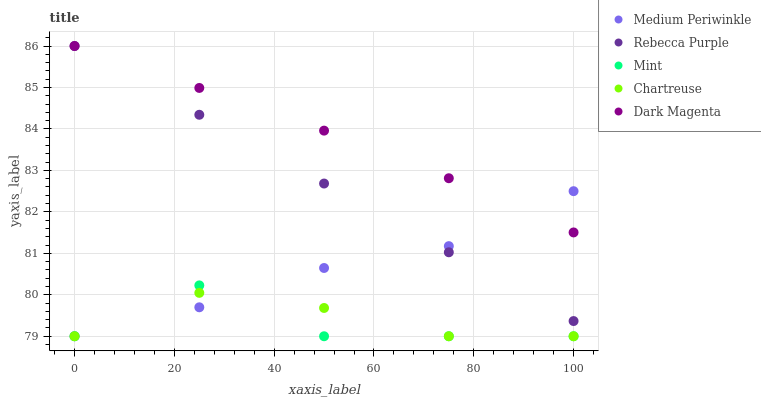Does Mint have the minimum area under the curve?
Answer yes or no. Yes. Does Dark Magenta have the maximum area under the curve?
Answer yes or no. Yes. Does Chartreuse have the minimum area under the curve?
Answer yes or no. No. Does Chartreuse have the maximum area under the curve?
Answer yes or no. No. Is Rebecca Purple the smoothest?
Answer yes or no. Yes. Is Mint the roughest?
Answer yes or no. Yes. Is Chartreuse the smoothest?
Answer yes or no. No. Is Chartreuse the roughest?
Answer yes or no. No. Does Mint have the lowest value?
Answer yes or no. Yes. Does Rebecca Purple have the lowest value?
Answer yes or no. No. Does Dark Magenta have the highest value?
Answer yes or no. Yes. Does Medium Periwinkle have the highest value?
Answer yes or no. No. Is Chartreuse less than Dark Magenta?
Answer yes or no. Yes. Is Dark Magenta greater than Chartreuse?
Answer yes or no. Yes. Does Dark Magenta intersect Rebecca Purple?
Answer yes or no. Yes. Is Dark Magenta less than Rebecca Purple?
Answer yes or no. No. Is Dark Magenta greater than Rebecca Purple?
Answer yes or no. No. Does Chartreuse intersect Dark Magenta?
Answer yes or no. No. 